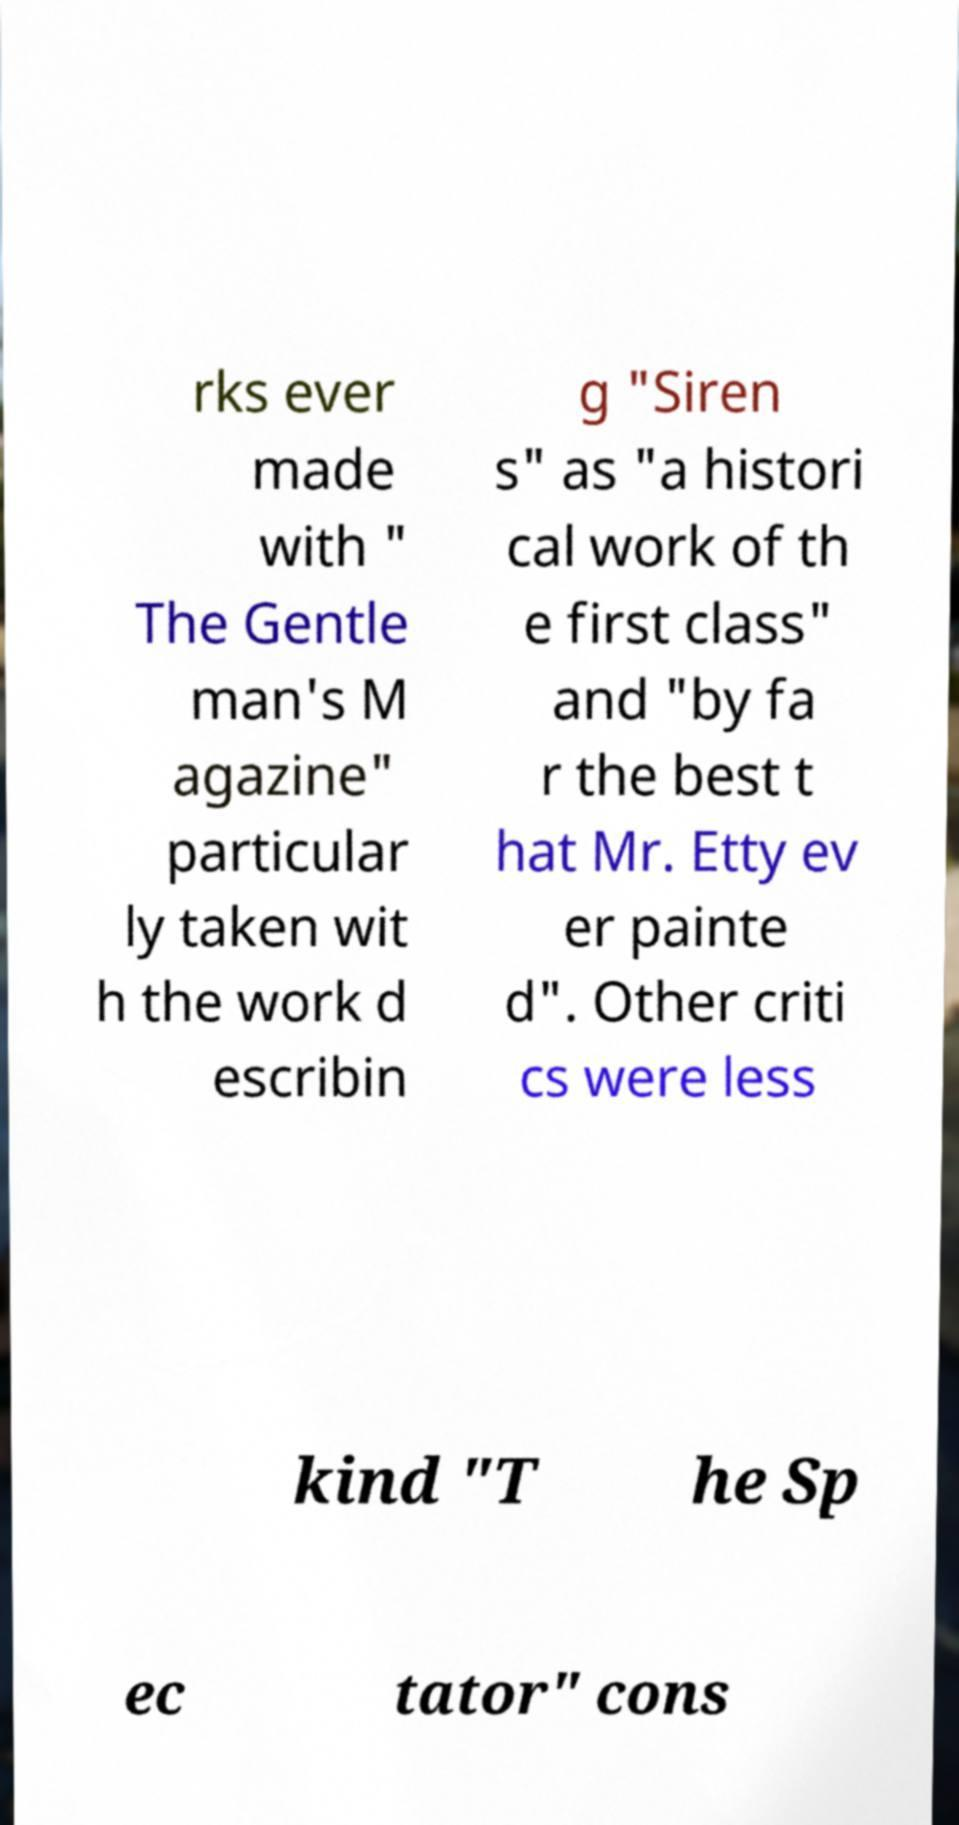Could you assist in decoding the text presented in this image and type it out clearly? rks ever made with " The Gentle man's M agazine" particular ly taken wit h the work d escribin g "Siren s" as "a histori cal work of th e first class" and "by fa r the best t hat Mr. Etty ev er painte d". Other criti cs were less kind "T he Sp ec tator" cons 